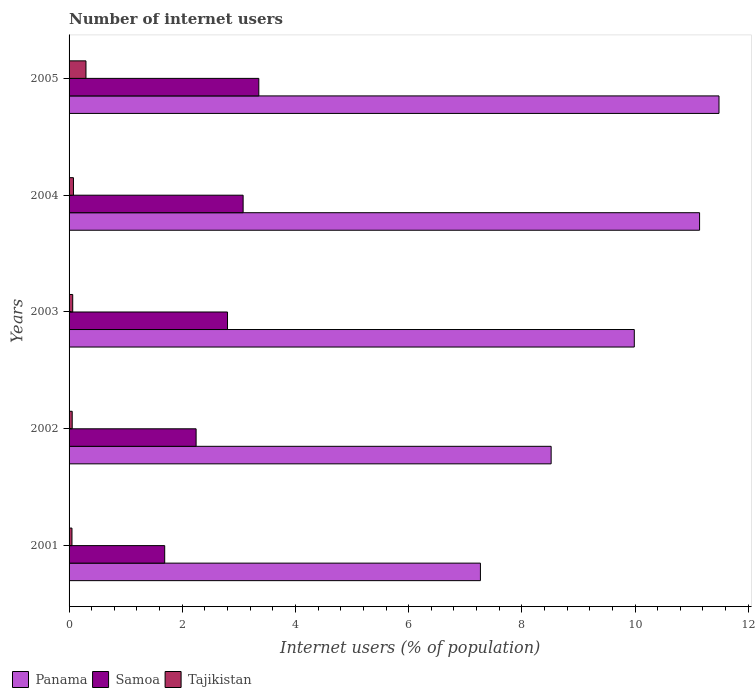How many different coloured bars are there?
Your answer should be very brief. 3. How many groups of bars are there?
Your answer should be compact. 5. How many bars are there on the 2nd tick from the top?
Ensure brevity in your answer.  3. How many bars are there on the 3rd tick from the bottom?
Provide a short and direct response. 3. What is the label of the 3rd group of bars from the top?
Keep it short and to the point. 2003. What is the number of internet users in Tajikistan in 2001?
Ensure brevity in your answer.  0.05. Across all years, what is the maximum number of internet users in Panama?
Give a very brief answer. 11.48. Across all years, what is the minimum number of internet users in Panama?
Offer a terse response. 7.27. In which year was the number of internet users in Samoa minimum?
Offer a very short reply. 2001. What is the total number of internet users in Tajikistan in the graph?
Provide a succinct answer. 0.55. What is the difference between the number of internet users in Tajikistan in 2001 and that in 2002?
Give a very brief answer. -0. What is the difference between the number of internet users in Panama in 2004 and the number of internet users in Tajikistan in 2002?
Your answer should be very brief. 11.09. What is the average number of internet users in Samoa per year?
Provide a succinct answer. 2.63. In the year 2003, what is the difference between the number of internet users in Panama and number of internet users in Samoa?
Your answer should be compact. 7.19. In how many years, is the number of internet users in Panama greater than 11.2 %?
Offer a terse response. 1. What is the ratio of the number of internet users in Samoa in 2002 to that in 2004?
Your answer should be very brief. 0.73. What is the difference between the highest and the second highest number of internet users in Samoa?
Ensure brevity in your answer.  0.28. What is the difference between the highest and the lowest number of internet users in Tajikistan?
Provide a short and direct response. 0.25. What does the 2nd bar from the top in 2002 represents?
Provide a succinct answer. Samoa. What does the 2nd bar from the bottom in 2005 represents?
Make the answer very short. Samoa. How many bars are there?
Provide a succinct answer. 15. How many years are there in the graph?
Make the answer very short. 5. What is the difference between two consecutive major ticks on the X-axis?
Keep it short and to the point. 2. Are the values on the major ticks of X-axis written in scientific E-notation?
Offer a very short reply. No. Does the graph contain any zero values?
Make the answer very short. No. Does the graph contain grids?
Give a very brief answer. No. Where does the legend appear in the graph?
Your answer should be very brief. Bottom left. How many legend labels are there?
Your answer should be very brief. 3. How are the legend labels stacked?
Your answer should be compact. Horizontal. What is the title of the graph?
Your answer should be compact. Number of internet users. Does "Brunei Darussalam" appear as one of the legend labels in the graph?
Your answer should be very brief. No. What is the label or title of the X-axis?
Give a very brief answer. Internet users (% of population). What is the Internet users (% of population) of Panama in 2001?
Keep it short and to the point. 7.27. What is the Internet users (% of population) in Samoa in 2001?
Your response must be concise. 1.69. What is the Internet users (% of population) in Tajikistan in 2001?
Provide a short and direct response. 0.05. What is the Internet users (% of population) of Panama in 2002?
Your answer should be very brief. 8.52. What is the Internet users (% of population) of Samoa in 2002?
Make the answer very short. 2.24. What is the Internet users (% of population) in Tajikistan in 2002?
Provide a succinct answer. 0.06. What is the Internet users (% of population) of Panama in 2003?
Provide a succinct answer. 9.99. What is the Internet users (% of population) in Samoa in 2003?
Provide a short and direct response. 2.8. What is the Internet users (% of population) of Tajikistan in 2003?
Keep it short and to the point. 0.06. What is the Internet users (% of population) of Panama in 2004?
Ensure brevity in your answer.  11.14. What is the Internet users (% of population) of Samoa in 2004?
Your answer should be very brief. 3.08. What is the Internet users (% of population) in Tajikistan in 2004?
Offer a very short reply. 0.08. What is the Internet users (% of population) of Panama in 2005?
Your answer should be very brief. 11.48. What is the Internet users (% of population) of Samoa in 2005?
Ensure brevity in your answer.  3.35. What is the Internet users (% of population) in Tajikistan in 2005?
Your response must be concise. 0.3. Across all years, what is the maximum Internet users (% of population) of Panama?
Offer a terse response. 11.48. Across all years, what is the maximum Internet users (% of population) of Samoa?
Ensure brevity in your answer.  3.35. Across all years, what is the maximum Internet users (% of population) in Tajikistan?
Provide a short and direct response. 0.3. Across all years, what is the minimum Internet users (% of population) of Panama?
Offer a very short reply. 7.27. Across all years, what is the minimum Internet users (% of population) of Samoa?
Make the answer very short. 1.69. Across all years, what is the minimum Internet users (% of population) of Tajikistan?
Provide a succinct answer. 0.05. What is the total Internet users (% of population) in Panama in the graph?
Offer a very short reply. 48.4. What is the total Internet users (% of population) of Samoa in the graph?
Offer a very short reply. 13.16. What is the total Internet users (% of population) of Tajikistan in the graph?
Keep it short and to the point. 0.55. What is the difference between the Internet users (% of population) of Panama in 2001 and that in 2002?
Provide a succinct answer. -1.25. What is the difference between the Internet users (% of population) of Samoa in 2001 and that in 2002?
Provide a short and direct response. -0.55. What is the difference between the Internet users (% of population) in Tajikistan in 2001 and that in 2002?
Offer a very short reply. -0. What is the difference between the Internet users (% of population) in Panama in 2001 and that in 2003?
Give a very brief answer. -2.72. What is the difference between the Internet users (% of population) in Samoa in 2001 and that in 2003?
Offer a very short reply. -1.11. What is the difference between the Internet users (% of population) of Tajikistan in 2001 and that in 2003?
Your response must be concise. -0.01. What is the difference between the Internet users (% of population) of Panama in 2001 and that in 2004?
Your answer should be compact. -3.87. What is the difference between the Internet users (% of population) in Samoa in 2001 and that in 2004?
Give a very brief answer. -1.39. What is the difference between the Internet users (% of population) of Tajikistan in 2001 and that in 2004?
Make the answer very short. -0.03. What is the difference between the Internet users (% of population) of Panama in 2001 and that in 2005?
Your answer should be compact. -4.22. What is the difference between the Internet users (% of population) in Samoa in 2001 and that in 2005?
Your response must be concise. -1.66. What is the difference between the Internet users (% of population) of Tajikistan in 2001 and that in 2005?
Make the answer very short. -0.25. What is the difference between the Internet users (% of population) in Panama in 2002 and that in 2003?
Offer a terse response. -1.47. What is the difference between the Internet users (% of population) of Samoa in 2002 and that in 2003?
Make the answer very short. -0.55. What is the difference between the Internet users (% of population) of Tajikistan in 2002 and that in 2003?
Ensure brevity in your answer.  -0.01. What is the difference between the Internet users (% of population) in Panama in 2002 and that in 2004?
Provide a succinct answer. -2.62. What is the difference between the Internet users (% of population) in Samoa in 2002 and that in 2004?
Your response must be concise. -0.83. What is the difference between the Internet users (% of population) of Tajikistan in 2002 and that in 2004?
Provide a short and direct response. -0.02. What is the difference between the Internet users (% of population) of Panama in 2002 and that in 2005?
Make the answer very short. -2.97. What is the difference between the Internet users (% of population) in Samoa in 2002 and that in 2005?
Give a very brief answer. -1.11. What is the difference between the Internet users (% of population) in Tajikistan in 2002 and that in 2005?
Offer a very short reply. -0.24. What is the difference between the Internet users (% of population) in Panama in 2003 and that in 2004?
Ensure brevity in your answer.  -1.15. What is the difference between the Internet users (% of population) in Samoa in 2003 and that in 2004?
Offer a terse response. -0.28. What is the difference between the Internet users (% of population) of Tajikistan in 2003 and that in 2004?
Your answer should be very brief. -0.01. What is the difference between the Internet users (% of population) of Panama in 2003 and that in 2005?
Provide a short and direct response. -1.5. What is the difference between the Internet users (% of population) in Samoa in 2003 and that in 2005?
Ensure brevity in your answer.  -0.55. What is the difference between the Internet users (% of population) of Tajikistan in 2003 and that in 2005?
Provide a succinct answer. -0.23. What is the difference between the Internet users (% of population) of Panama in 2004 and that in 2005?
Offer a very short reply. -0.34. What is the difference between the Internet users (% of population) of Samoa in 2004 and that in 2005?
Provide a succinct answer. -0.28. What is the difference between the Internet users (% of population) of Tajikistan in 2004 and that in 2005?
Offer a very short reply. -0.22. What is the difference between the Internet users (% of population) in Panama in 2001 and the Internet users (% of population) in Samoa in 2002?
Make the answer very short. 5.02. What is the difference between the Internet users (% of population) of Panama in 2001 and the Internet users (% of population) of Tajikistan in 2002?
Make the answer very short. 7.21. What is the difference between the Internet users (% of population) in Samoa in 2001 and the Internet users (% of population) in Tajikistan in 2002?
Provide a succinct answer. 1.63. What is the difference between the Internet users (% of population) of Panama in 2001 and the Internet users (% of population) of Samoa in 2003?
Offer a very short reply. 4.47. What is the difference between the Internet users (% of population) in Panama in 2001 and the Internet users (% of population) in Tajikistan in 2003?
Give a very brief answer. 7.2. What is the difference between the Internet users (% of population) in Samoa in 2001 and the Internet users (% of population) in Tajikistan in 2003?
Your response must be concise. 1.63. What is the difference between the Internet users (% of population) in Panama in 2001 and the Internet users (% of population) in Samoa in 2004?
Your response must be concise. 4.19. What is the difference between the Internet users (% of population) of Panama in 2001 and the Internet users (% of population) of Tajikistan in 2004?
Your answer should be very brief. 7.19. What is the difference between the Internet users (% of population) of Samoa in 2001 and the Internet users (% of population) of Tajikistan in 2004?
Your response must be concise. 1.61. What is the difference between the Internet users (% of population) of Panama in 2001 and the Internet users (% of population) of Samoa in 2005?
Make the answer very short. 3.92. What is the difference between the Internet users (% of population) of Panama in 2001 and the Internet users (% of population) of Tajikistan in 2005?
Your answer should be very brief. 6.97. What is the difference between the Internet users (% of population) of Samoa in 2001 and the Internet users (% of population) of Tajikistan in 2005?
Keep it short and to the point. 1.39. What is the difference between the Internet users (% of population) of Panama in 2002 and the Internet users (% of population) of Samoa in 2003?
Ensure brevity in your answer.  5.72. What is the difference between the Internet users (% of population) in Panama in 2002 and the Internet users (% of population) in Tajikistan in 2003?
Keep it short and to the point. 8.45. What is the difference between the Internet users (% of population) of Samoa in 2002 and the Internet users (% of population) of Tajikistan in 2003?
Offer a terse response. 2.18. What is the difference between the Internet users (% of population) of Panama in 2002 and the Internet users (% of population) of Samoa in 2004?
Your answer should be compact. 5.44. What is the difference between the Internet users (% of population) in Panama in 2002 and the Internet users (% of population) in Tajikistan in 2004?
Your answer should be compact. 8.44. What is the difference between the Internet users (% of population) of Samoa in 2002 and the Internet users (% of population) of Tajikistan in 2004?
Your answer should be very brief. 2.17. What is the difference between the Internet users (% of population) of Panama in 2002 and the Internet users (% of population) of Samoa in 2005?
Offer a very short reply. 5.17. What is the difference between the Internet users (% of population) of Panama in 2002 and the Internet users (% of population) of Tajikistan in 2005?
Offer a very short reply. 8.22. What is the difference between the Internet users (% of population) in Samoa in 2002 and the Internet users (% of population) in Tajikistan in 2005?
Offer a terse response. 1.95. What is the difference between the Internet users (% of population) of Panama in 2003 and the Internet users (% of population) of Samoa in 2004?
Ensure brevity in your answer.  6.91. What is the difference between the Internet users (% of population) in Panama in 2003 and the Internet users (% of population) in Tajikistan in 2004?
Your answer should be very brief. 9.91. What is the difference between the Internet users (% of population) in Samoa in 2003 and the Internet users (% of population) in Tajikistan in 2004?
Your answer should be very brief. 2.72. What is the difference between the Internet users (% of population) in Panama in 2003 and the Internet users (% of population) in Samoa in 2005?
Ensure brevity in your answer.  6.63. What is the difference between the Internet users (% of population) in Panama in 2003 and the Internet users (% of population) in Tajikistan in 2005?
Your response must be concise. 9.69. What is the difference between the Internet users (% of population) in Samoa in 2003 and the Internet users (% of population) in Tajikistan in 2005?
Give a very brief answer. 2.5. What is the difference between the Internet users (% of population) of Panama in 2004 and the Internet users (% of population) of Samoa in 2005?
Make the answer very short. 7.79. What is the difference between the Internet users (% of population) of Panama in 2004 and the Internet users (% of population) of Tajikistan in 2005?
Your response must be concise. 10.84. What is the difference between the Internet users (% of population) of Samoa in 2004 and the Internet users (% of population) of Tajikistan in 2005?
Your answer should be compact. 2.78. What is the average Internet users (% of population) of Panama per year?
Give a very brief answer. 9.68. What is the average Internet users (% of population) in Samoa per year?
Give a very brief answer. 2.63. What is the average Internet users (% of population) in Tajikistan per year?
Your answer should be very brief. 0.11. In the year 2001, what is the difference between the Internet users (% of population) of Panama and Internet users (% of population) of Samoa?
Keep it short and to the point. 5.58. In the year 2001, what is the difference between the Internet users (% of population) of Panama and Internet users (% of population) of Tajikistan?
Your response must be concise. 7.22. In the year 2001, what is the difference between the Internet users (% of population) in Samoa and Internet users (% of population) in Tajikistan?
Offer a very short reply. 1.64. In the year 2002, what is the difference between the Internet users (% of population) in Panama and Internet users (% of population) in Samoa?
Give a very brief answer. 6.27. In the year 2002, what is the difference between the Internet users (% of population) in Panama and Internet users (% of population) in Tajikistan?
Ensure brevity in your answer.  8.46. In the year 2002, what is the difference between the Internet users (% of population) in Samoa and Internet users (% of population) in Tajikistan?
Your answer should be very brief. 2.19. In the year 2003, what is the difference between the Internet users (% of population) in Panama and Internet users (% of population) in Samoa?
Offer a very short reply. 7.19. In the year 2003, what is the difference between the Internet users (% of population) of Panama and Internet users (% of population) of Tajikistan?
Offer a terse response. 9.92. In the year 2003, what is the difference between the Internet users (% of population) in Samoa and Internet users (% of population) in Tajikistan?
Make the answer very short. 2.73. In the year 2004, what is the difference between the Internet users (% of population) in Panama and Internet users (% of population) in Samoa?
Provide a succinct answer. 8.07. In the year 2004, what is the difference between the Internet users (% of population) of Panama and Internet users (% of population) of Tajikistan?
Your answer should be very brief. 11.06. In the year 2004, what is the difference between the Internet users (% of population) in Samoa and Internet users (% of population) in Tajikistan?
Provide a succinct answer. 3. In the year 2005, what is the difference between the Internet users (% of population) of Panama and Internet users (% of population) of Samoa?
Your answer should be very brief. 8.13. In the year 2005, what is the difference between the Internet users (% of population) of Panama and Internet users (% of population) of Tajikistan?
Provide a short and direct response. 11.19. In the year 2005, what is the difference between the Internet users (% of population) of Samoa and Internet users (% of population) of Tajikistan?
Your response must be concise. 3.05. What is the ratio of the Internet users (% of population) in Panama in 2001 to that in 2002?
Give a very brief answer. 0.85. What is the ratio of the Internet users (% of population) in Samoa in 2001 to that in 2002?
Make the answer very short. 0.75. What is the ratio of the Internet users (% of population) of Tajikistan in 2001 to that in 2002?
Offer a terse response. 0.92. What is the ratio of the Internet users (% of population) in Panama in 2001 to that in 2003?
Your response must be concise. 0.73. What is the ratio of the Internet users (% of population) in Samoa in 2001 to that in 2003?
Ensure brevity in your answer.  0.6. What is the ratio of the Internet users (% of population) of Tajikistan in 2001 to that in 2003?
Your answer should be compact. 0.79. What is the ratio of the Internet users (% of population) of Panama in 2001 to that in 2004?
Your answer should be very brief. 0.65. What is the ratio of the Internet users (% of population) in Samoa in 2001 to that in 2004?
Ensure brevity in your answer.  0.55. What is the ratio of the Internet users (% of population) of Tajikistan in 2001 to that in 2004?
Your answer should be compact. 0.66. What is the ratio of the Internet users (% of population) of Panama in 2001 to that in 2005?
Offer a terse response. 0.63. What is the ratio of the Internet users (% of population) in Samoa in 2001 to that in 2005?
Provide a short and direct response. 0.5. What is the ratio of the Internet users (% of population) of Tajikistan in 2001 to that in 2005?
Offer a terse response. 0.17. What is the ratio of the Internet users (% of population) of Panama in 2002 to that in 2003?
Offer a very short reply. 0.85. What is the ratio of the Internet users (% of population) of Samoa in 2002 to that in 2003?
Ensure brevity in your answer.  0.8. What is the ratio of the Internet users (% of population) of Tajikistan in 2002 to that in 2003?
Make the answer very short. 0.86. What is the ratio of the Internet users (% of population) of Panama in 2002 to that in 2004?
Offer a terse response. 0.76. What is the ratio of the Internet users (% of population) in Samoa in 2002 to that in 2004?
Your response must be concise. 0.73. What is the ratio of the Internet users (% of population) of Tajikistan in 2002 to that in 2004?
Provide a succinct answer. 0.72. What is the ratio of the Internet users (% of population) of Panama in 2002 to that in 2005?
Give a very brief answer. 0.74. What is the ratio of the Internet users (% of population) of Samoa in 2002 to that in 2005?
Provide a short and direct response. 0.67. What is the ratio of the Internet users (% of population) in Tajikistan in 2002 to that in 2005?
Provide a short and direct response. 0.19. What is the ratio of the Internet users (% of population) in Panama in 2003 to that in 2004?
Make the answer very short. 0.9. What is the ratio of the Internet users (% of population) of Samoa in 2003 to that in 2004?
Your answer should be very brief. 0.91. What is the ratio of the Internet users (% of population) in Tajikistan in 2003 to that in 2004?
Ensure brevity in your answer.  0.83. What is the ratio of the Internet users (% of population) in Panama in 2003 to that in 2005?
Offer a terse response. 0.87. What is the ratio of the Internet users (% of population) in Samoa in 2003 to that in 2005?
Your response must be concise. 0.84. What is the ratio of the Internet users (% of population) in Tajikistan in 2003 to that in 2005?
Provide a short and direct response. 0.22. What is the ratio of the Internet users (% of population) of Panama in 2004 to that in 2005?
Offer a terse response. 0.97. What is the ratio of the Internet users (% of population) in Samoa in 2004 to that in 2005?
Your answer should be very brief. 0.92. What is the ratio of the Internet users (% of population) of Tajikistan in 2004 to that in 2005?
Offer a very short reply. 0.26. What is the difference between the highest and the second highest Internet users (% of population) in Panama?
Your answer should be compact. 0.34. What is the difference between the highest and the second highest Internet users (% of population) of Samoa?
Provide a short and direct response. 0.28. What is the difference between the highest and the second highest Internet users (% of population) of Tajikistan?
Offer a terse response. 0.22. What is the difference between the highest and the lowest Internet users (% of population) in Panama?
Offer a terse response. 4.22. What is the difference between the highest and the lowest Internet users (% of population) of Samoa?
Keep it short and to the point. 1.66. What is the difference between the highest and the lowest Internet users (% of population) in Tajikistan?
Offer a terse response. 0.25. 